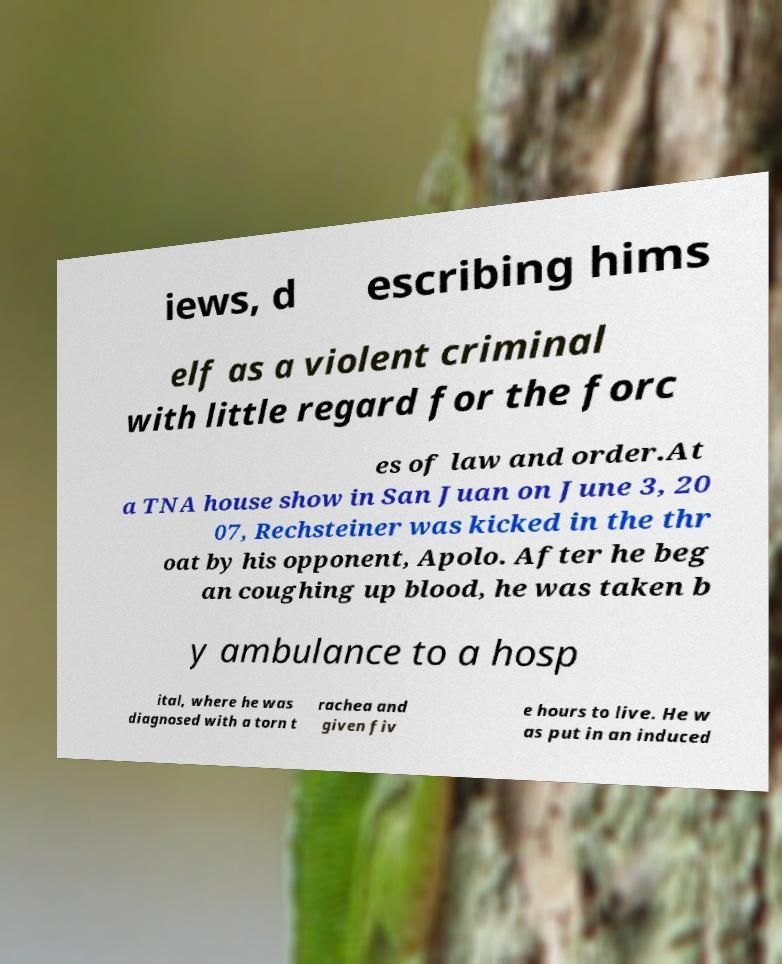For documentation purposes, I need the text within this image transcribed. Could you provide that? iews, d escribing hims elf as a violent criminal with little regard for the forc es of law and order.At a TNA house show in San Juan on June 3, 20 07, Rechsteiner was kicked in the thr oat by his opponent, Apolo. After he beg an coughing up blood, he was taken b y ambulance to a hosp ital, where he was diagnosed with a torn t rachea and given fiv e hours to live. He w as put in an induced 